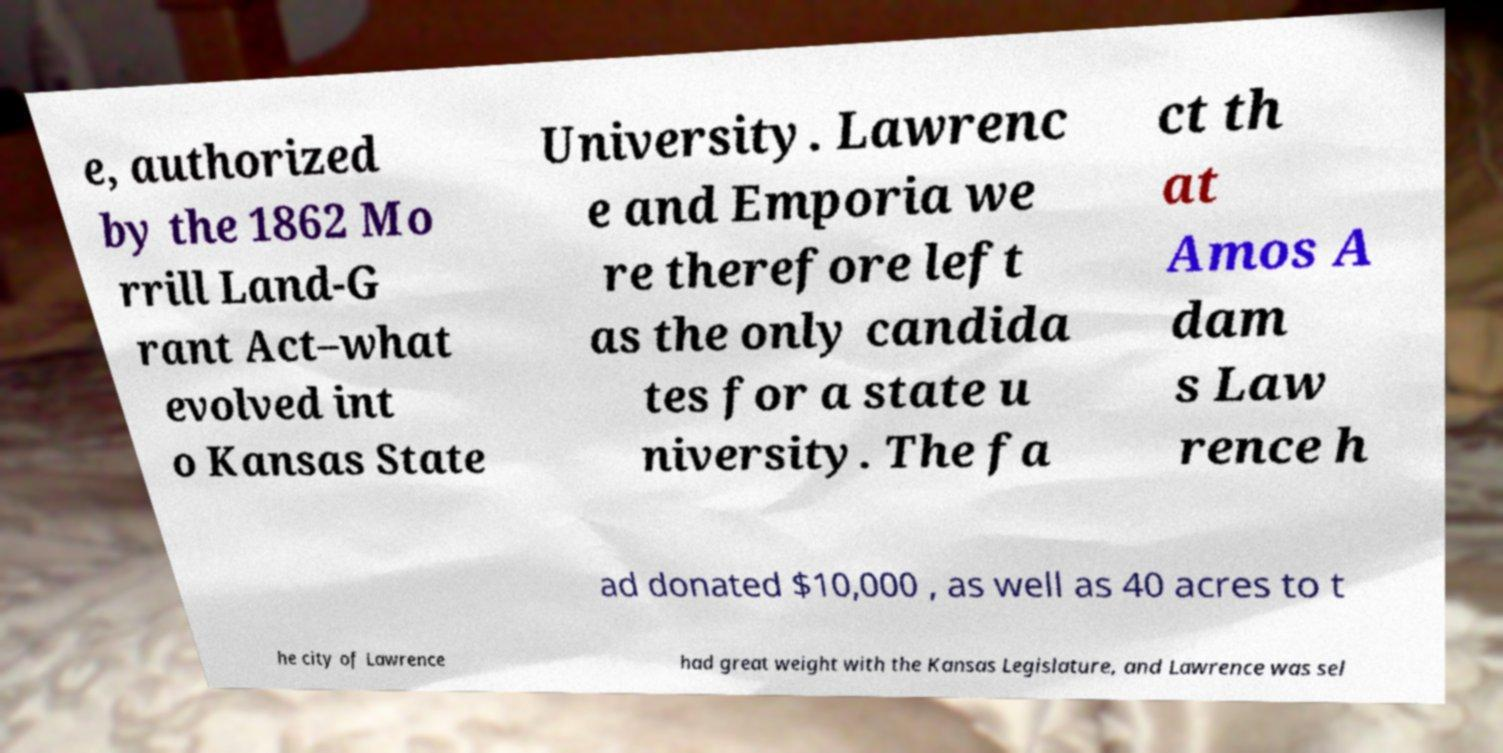I need the written content from this picture converted into text. Can you do that? e, authorized by the 1862 Mo rrill Land-G rant Act–what evolved int o Kansas State University. Lawrenc e and Emporia we re therefore left as the only candida tes for a state u niversity. The fa ct th at Amos A dam s Law rence h ad donated $10,000 , as well as 40 acres to t he city of Lawrence had great weight with the Kansas Legislature, and Lawrence was sel 